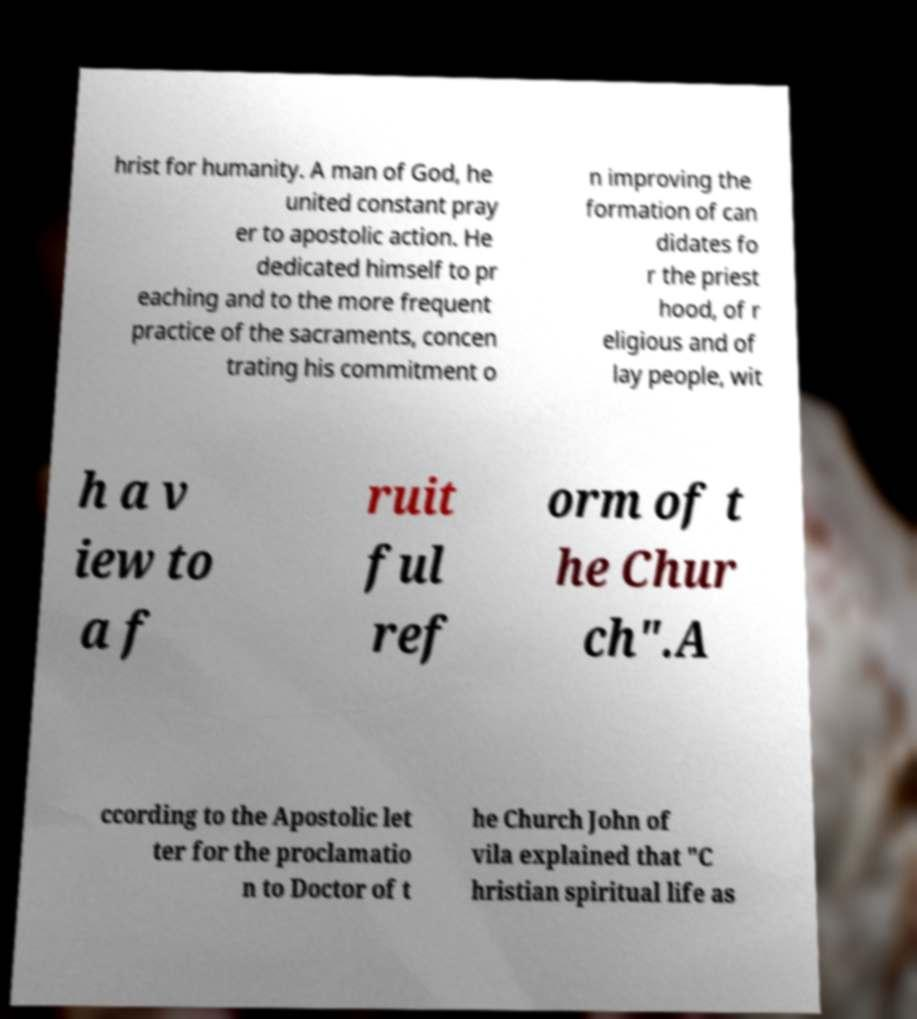What messages or text are displayed in this image? I need them in a readable, typed format. hrist for humanity. A man of God, he united constant pray er to apostolic action. He dedicated himself to pr eaching and to the more frequent practice of the sacraments, concen trating his commitment o n improving the formation of can didates fo r the priest hood, of r eligious and of lay people, wit h a v iew to a f ruit ful ref orm of t he Chur ch".A ccording to the Apostolic let ter for the proclamatio n to Doctor of t he Church John of vila explained that "C hristian spiritual life as 